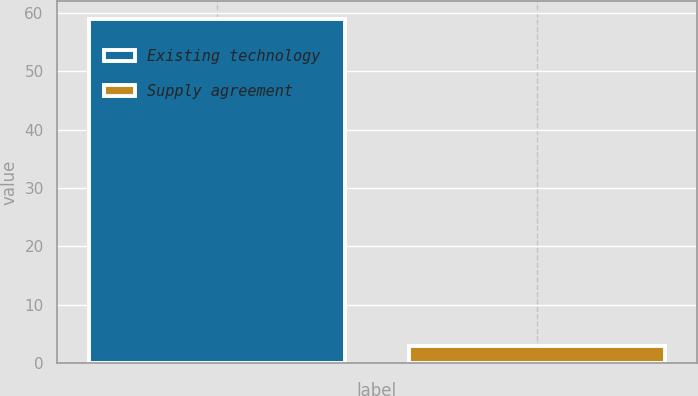Convert chart to OTSL. <chart><loc_0><loc_0><loc_500><loc_500><bar_chart><fcel>Existing technology<fcel>Supply agreement<nl><fcel>59<fcel>3<nl></chart> 